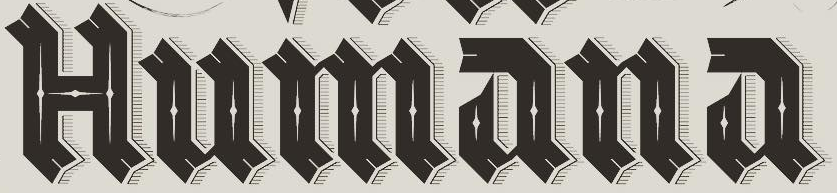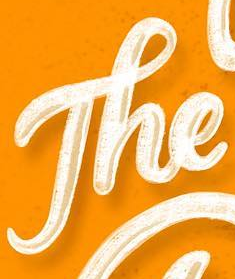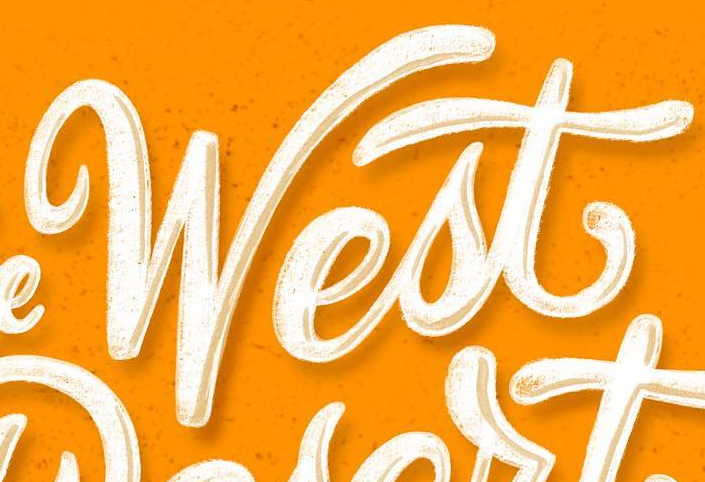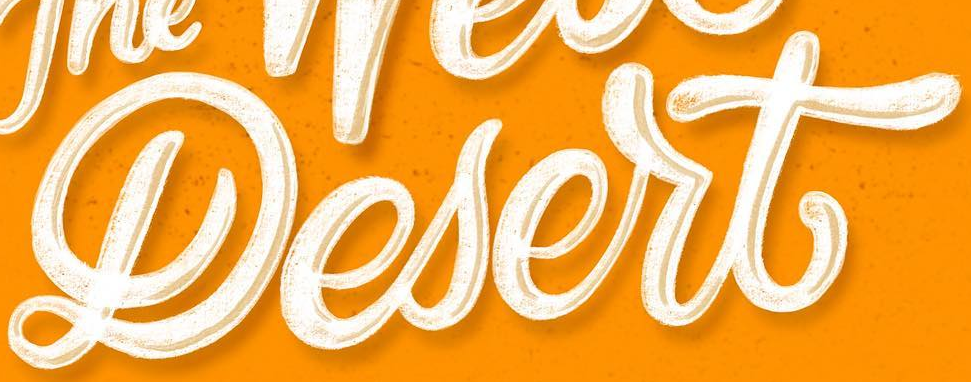What text appears in these images from left to right, separated by a semicolon? Humana; The; West; Lesert 